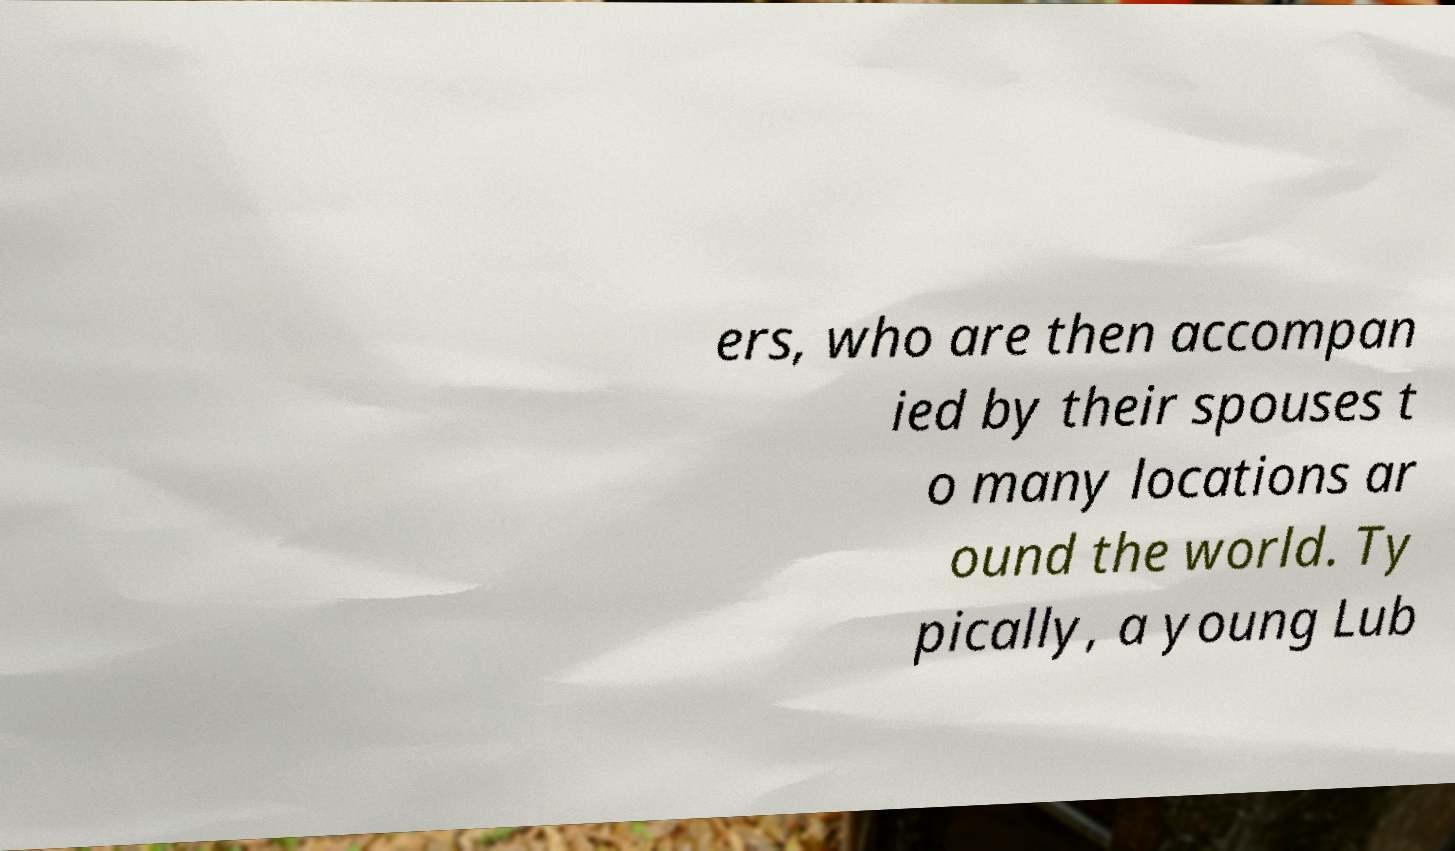Can you read and provide the text displayed in the image?This photo seems to have some interesting text. Can you extract and type it out for me? ers, who are then accompan ied by their spouses t o many locations ar ound the world. Ty pically, a young Lub 